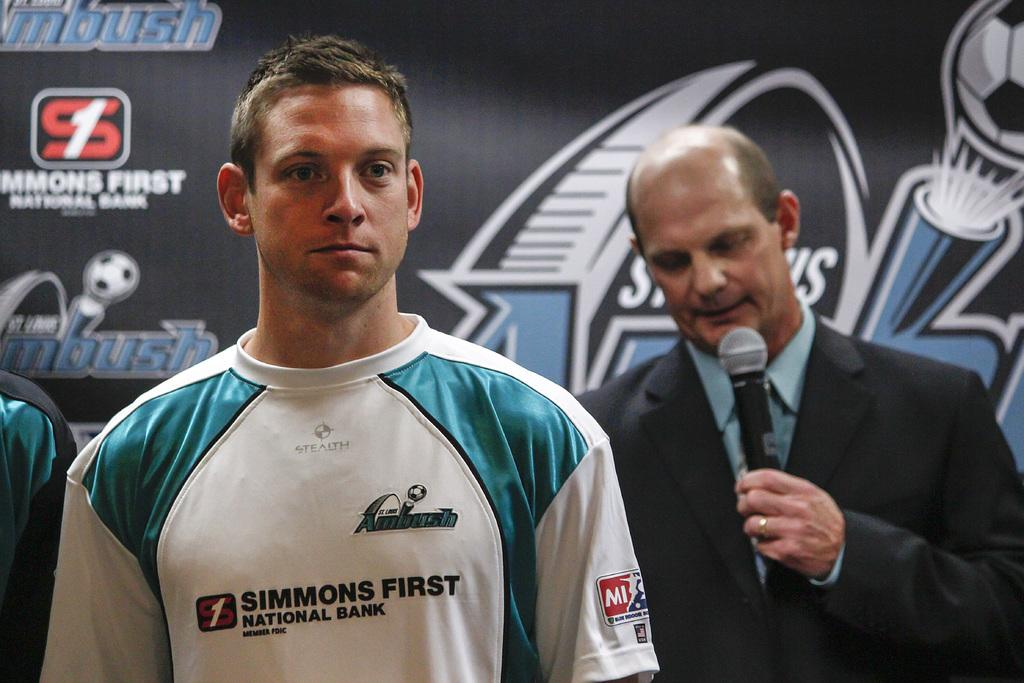<image>
Create a compact narrative representing the image presented. A man wears a shirt with the logo for Simmons First on it. 